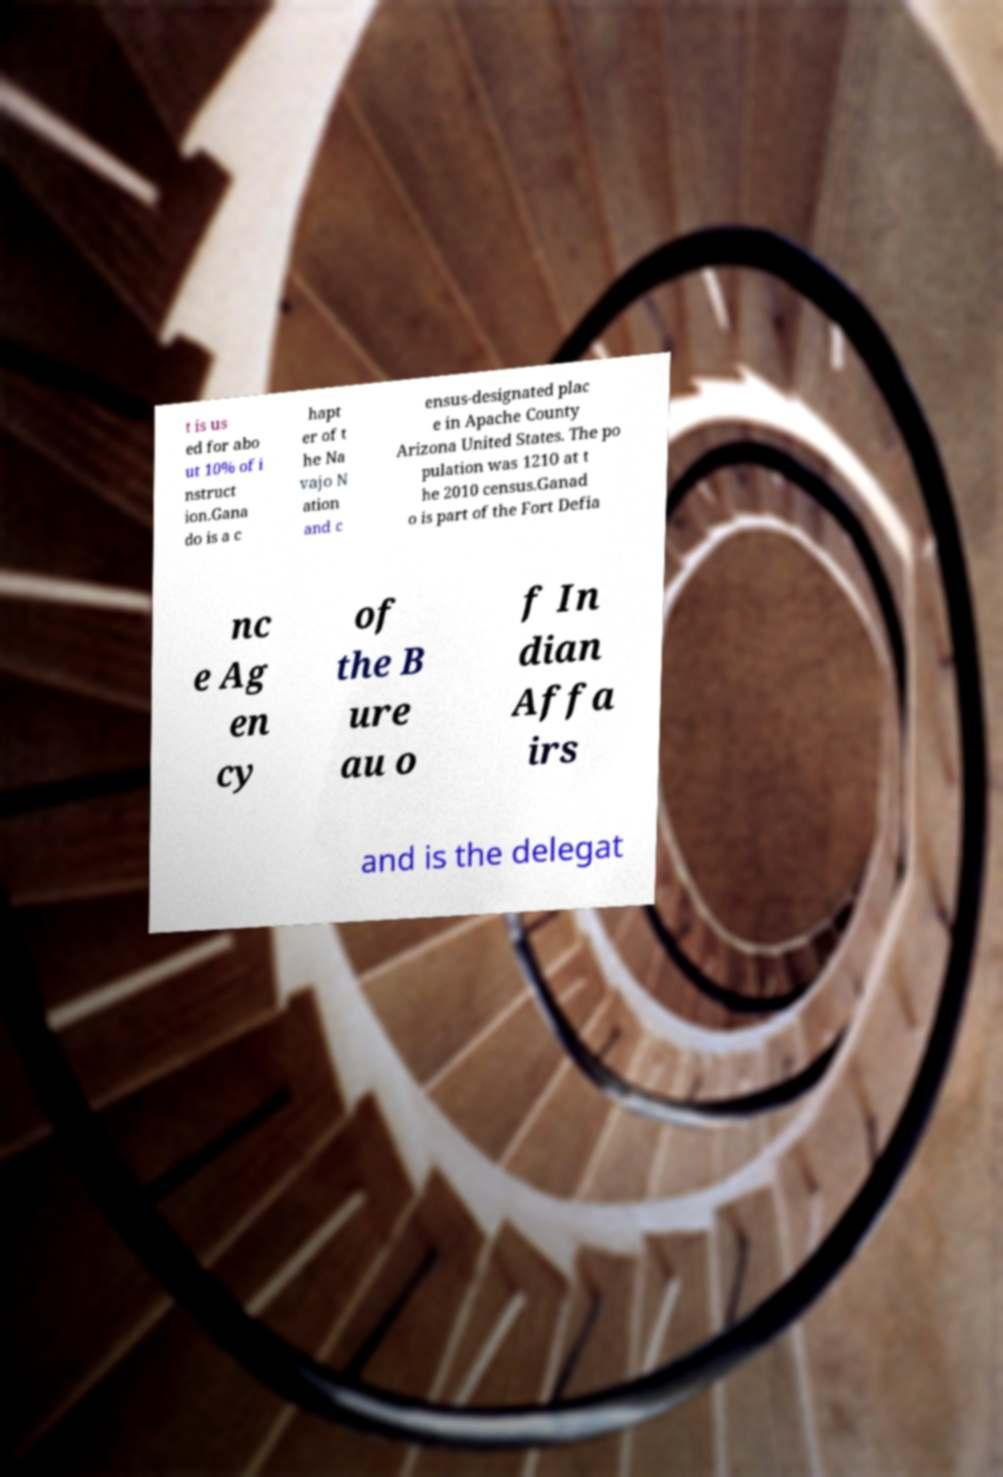Could you assist in decoding the text presented in this image and type it out clearly? t is us ed for abo ut 10% of i nstruct ion.Gana do is a c hapt er of t he Na vajo N ation and c ensus-designated plac e in Apache County Arizona United States. The po pulation was 1210 at t he 2010 census.Ganad o is part of the Fort Defia nc e Ag en cy of the B ure au o f In dian Affa irs and is the delegat 